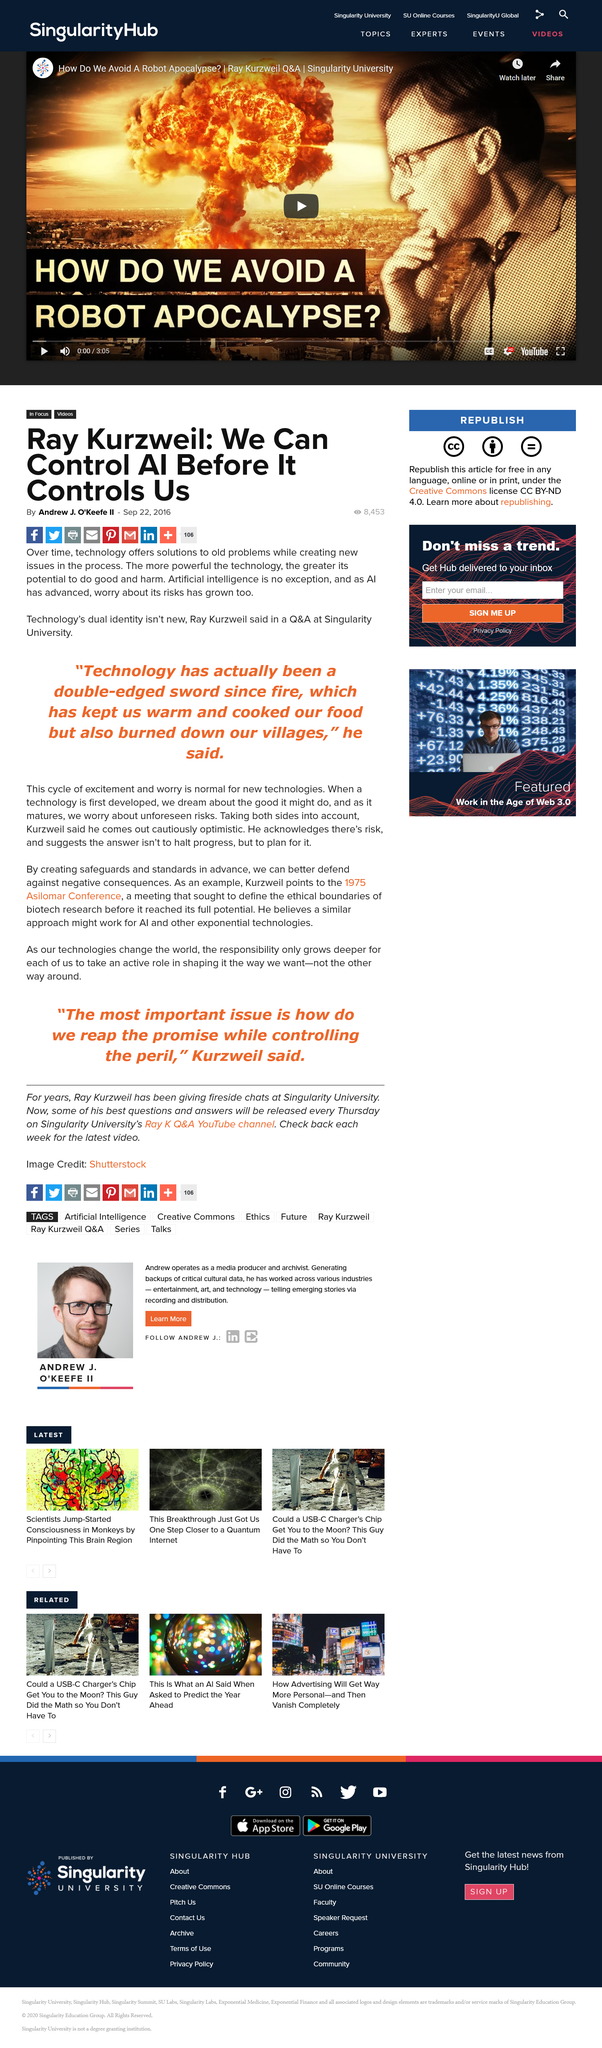List a handful of essential elements in this visual. Technology offers solutions to a wide range of problems, including those that have existed for a long time. In accordance with Ray Kurzweil's belief, preventing technology from creating new problems requires not halting progress, but rather preparing for it in advance. New technology, according to Ray Kurzweil, follows a cycle of excitement and worry. 